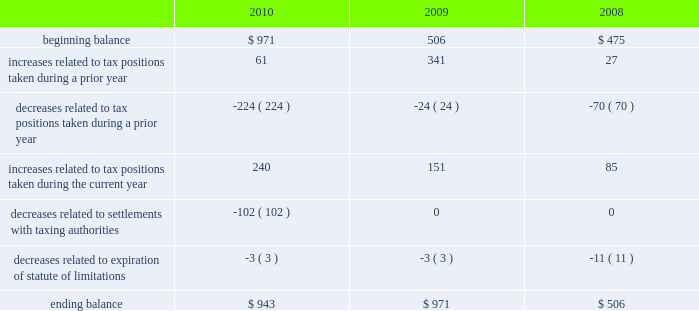Table of contents the aggregate changes in the balance of gross unrecognized tax benefits , which excludes interest and penalties , for the three years ended september 25 , 2010 , is as follows ( in millions ) : the company includes interest and penalties related to unrecognized tax benefits within the provision for income taxes .
As of september 25 , 2010 and september 26 , 2009 , the total amount of gross interest and penalties accrued was $ 247 million and $ 291 million , respectively , which is classified as non-current liabilities in the consolidated balance sheets .
In 2010 and 2009 , the company recognized an interest benefit of $ 43 million and interest expense of $ 64 million , respectively , in connection with tax matters .
The company is subject to taxation and files income tax returns in the u.s .
Federal jurisdiction and in many state and foreign jurisdictions .
For u.s .
Federal income tax purposes , all years prior to 2004 are closed .
The internal revenue service ( the 201cirs 201d ) has completed its field audit of the company 2019s federal income tax returns for the years 2004 through 2006 and proposed certain adjustments .
The company has contested certain of these adjustments through the irs appeals office .
The irs is currently examining the years 2007 through 2009 .
During the third quarter of 2010 , the company reached a tax settlement with the irs for the years 2002 through 2003 .
In connection with the settlement , the company reduced its gross unrecognized tax benefits by $ 100 million and recognized a $ 52 million tax benefit in the third quarter of 2010 .
In addition , the company is also subject to audits by state , local and foreign tax authorities .
In major states and major foreign jurisdictions , the years subsequent to 1988 and 2001 , respectively , generally remain open and could be subject to examination by the taxing authorities .
Management believes that an adequate provision has been made for any adjustments that may result from tax examinations .
However , the outcome of tax audits cannot be predicted with certainty .
If any issues addressed in the company 2019s tax audits are resolved in a manner not consistent with management 2019s expectations , the company could be required to adjust its provision for income tax in the period such resolution occurs .
Although timing of the resolution and/or closure of audits is not certain , the company does not believe it is reasonably possible that its unrecognized tax benefits would materially change in the next 12 months .
Note 7 2013 shareholders 2019 equity and stock-based compensation preferred stock the company has five million shares of authorized preferred stock , none of which is issued or outstanding .
Under the terms of the company 2019s restated articles of incorporation , the board of directors is authorized to determine or alter the rights , preferences , privileges and restrictions of the company 2019s authorized but unissued shares of preferred stock .
Comprehensive income comprehensive income consists of two components , net income and other comprehensive income .
Other comprehensive income refers to revenue , expenses , gains and losses that under gaap are recorded as an element of shareholders 2019 equity but are excluded from net income .
The company 2019s other comprehensive income consists .

What was the average ending balance of oci in millions? 
Computations: table_average(ending balance, none)
Answer: 806.66667. 